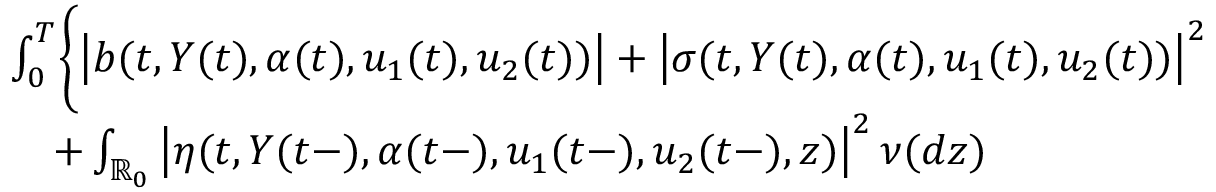Convert formula to latex. <formula><loc_0><loc_0><loc_500><loc_500>\begin{array} { r l } & { \int _ { 0 } ^ { T } \Big \{ \left | b ( t , Y ( t ) , \alpha ( t ) , u _ { 1 } ( t ) , u _ { 2 } ( t ) ) \right | + \left | \sigma ( t , Y ( t ) , \alpha ( t ) , u _ { 1 } ( t ) , u _ { 2 } ( t ) ) \right | ^ { 2 } } \\ & { \quad + \int _ { \mathbb { R } _ { 0 } } \left | \eta ( t , Y ( t - ) , \alpha ( t - ) , u _ { 1 } ( t - ) , u _ { 2 } ( t - ) , z ) \right | ^ { 2 } \nu ( d z ) } \end{array}</formula> 